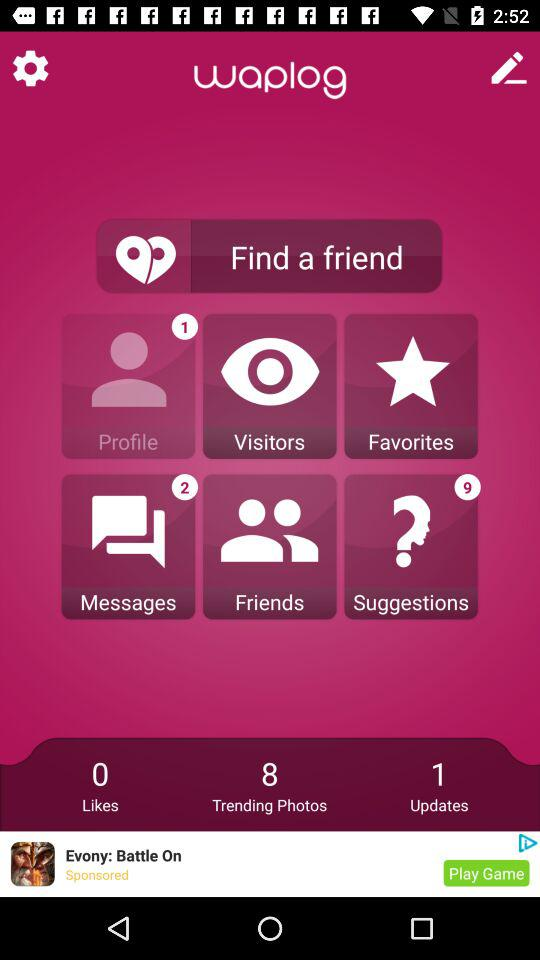How many suggestions are there in total? There are 9 suggestions in total. 